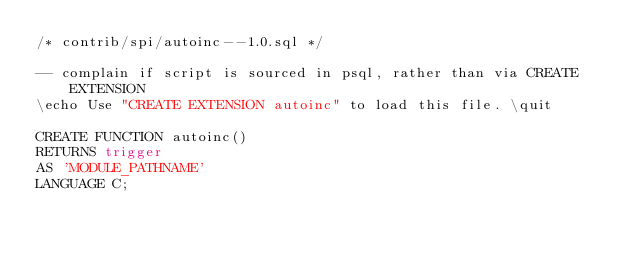<code> <loc_0><loc_0><loc_500><loc_500><_SQL_>/* contrib/spi/autoinc--1.0.sql */

-- complain if script is sourced in psql, rather than via CREATE EXTENSION
\echo Use "CREATE EXTENSION autoinc" to load this file. \quit

CREATE FUNCTION autoinc()
RETURNS trigger
AS 'MODULE_PATHNAME'
LANGUAGE C;
</code> 